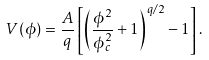Convert formula to latex. <formula><loc_0><loc_0><loc_500><loc_500>V ( \phi ) = \frac { A } { q } \left [ \left ( \frac { \phi ^ { 2 } } { \phi _ { c } ^ { 2 } } + 1 \right ) ^ { q / 2 } - 1 \right ] .</formula> 